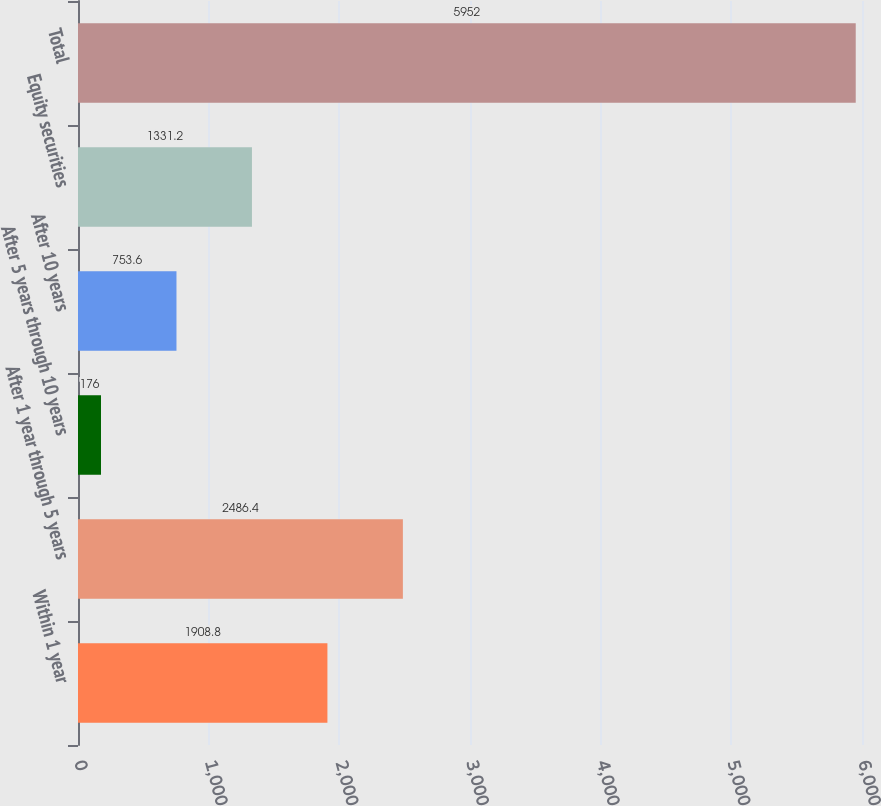Convert chart. <chart><loc_0><loc_0><loc_500><loc_500><bar_chart><fcel>Within 1 year<fcel>After 1 year through 5 years<fcel>After 5 years through 10 years<fcel>After 10 years<fcel>Equity securities<fcel>Total<nl><fcel>1908.8<fcel>2486.4<fcel>176<fcel>753.6<fcel>1331.2<fcel>5952<nl></chart> 